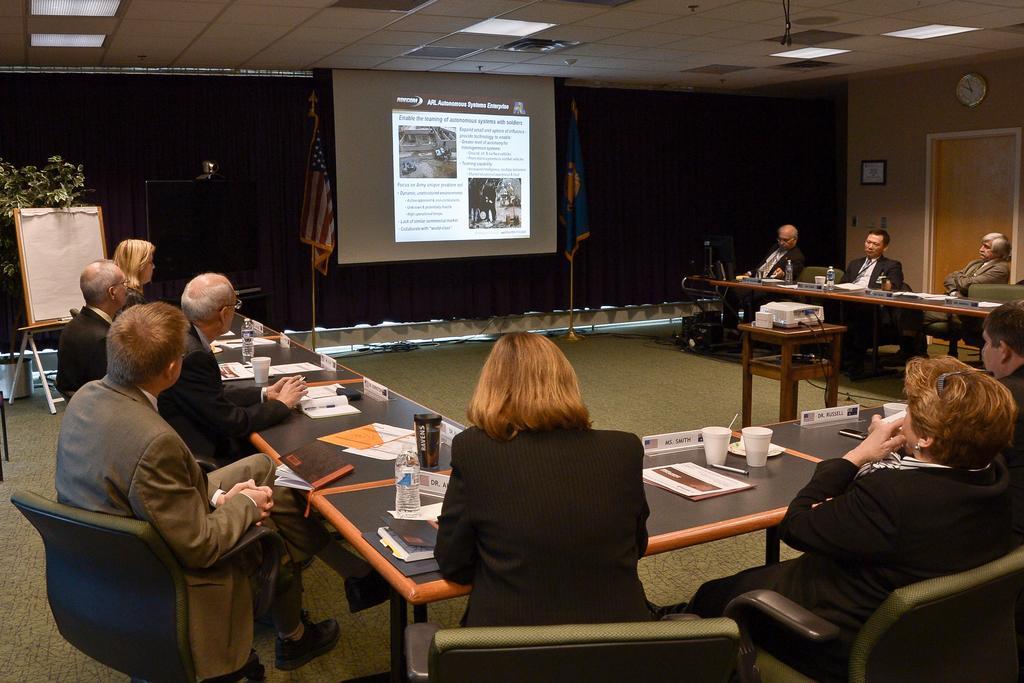How would you summarize this image in a sentence or two? As we can see in the image there is a screen, board, few people sitting on chairs and a table. On table there are bottles, glasses and papers. 